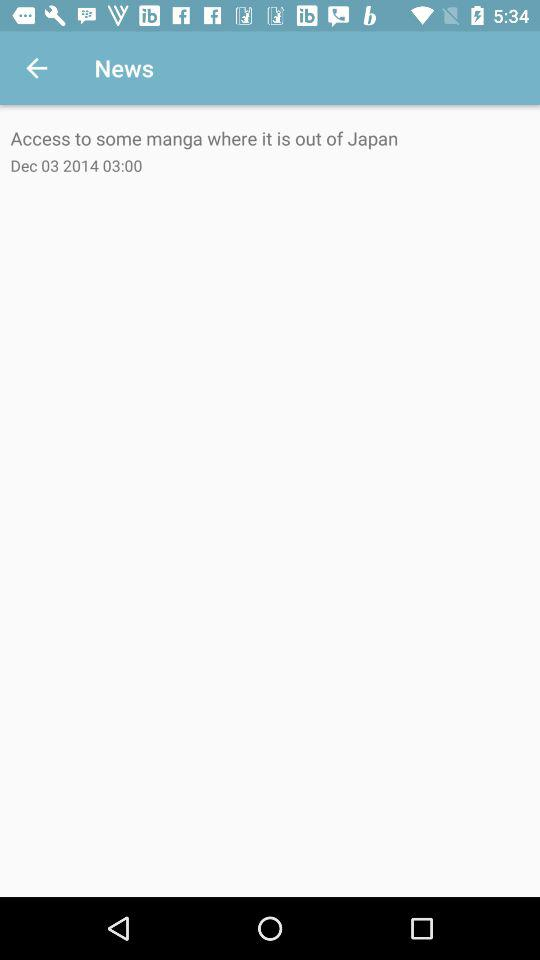What is the date and time of the news? The date and time of the news are December 3, 2014 and 03:00, respectively. 